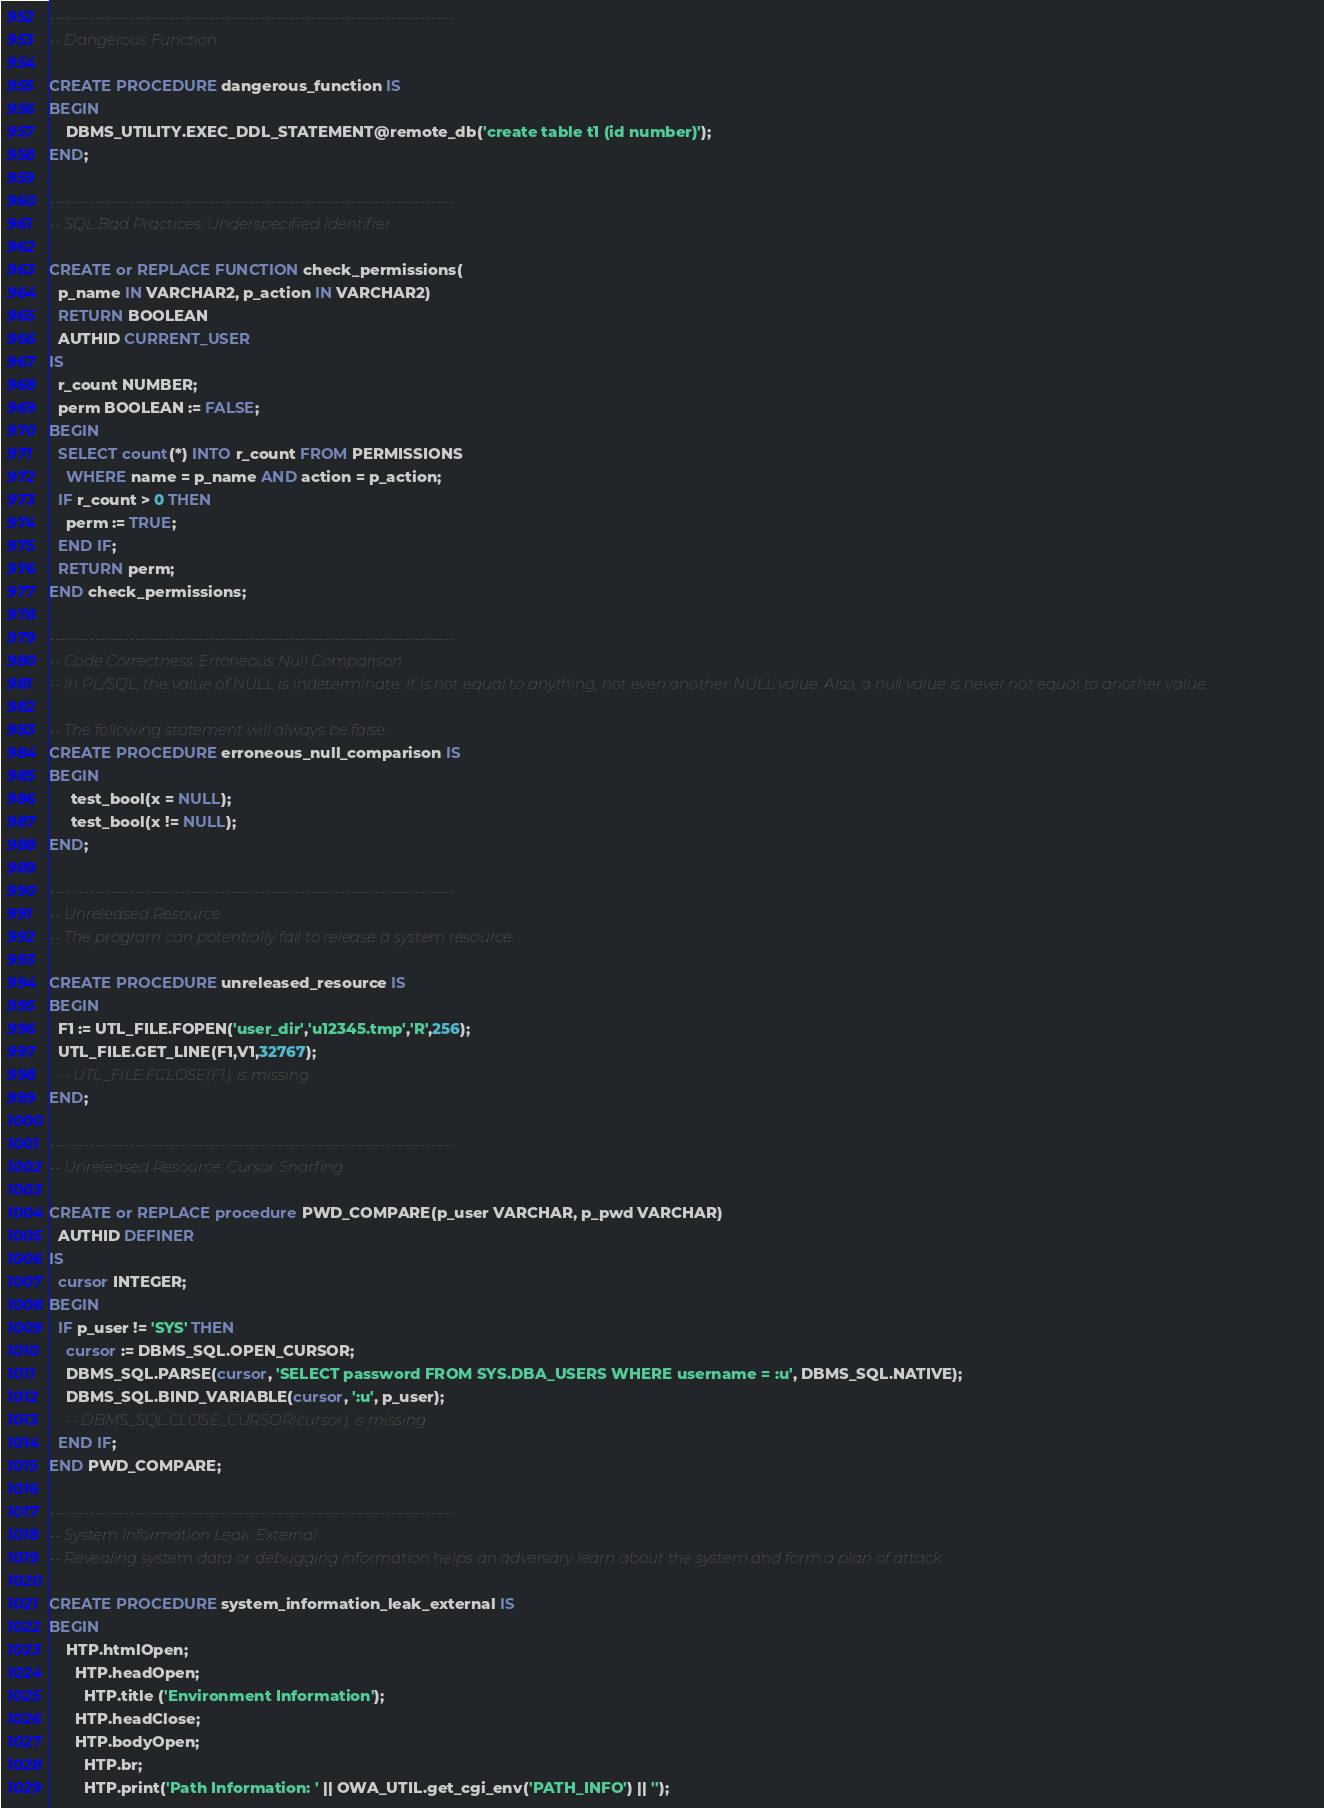<code> <loc_0><loc_0><loc_500><loc_500><_SQL_>-----------------------------------------------------------------------
-- Dangerous Function

CREATE PROCEDURE dangerous_function IS
BEGIN
    DBMS_UTILITY.EXEC_DDL_STATEMENT@remote_db('create table t1 (id number)');
END;

-----------------------------------------------------------------------
-- SQL Bad Practices: Underspecified Identifier

CREATE or REPLACE FUNCTION check_permissions(
  p_name IN VARCHAR2, p_action IN VARCHAR2)
  RETURN BOOLEAN
  AUTHID CURRENT_USER
IS
  r_count NUMBER;
  perm BOOLEAN := FALSE;
BEGIN
  SELECT count(*) INTO r_count FROM PERMISSIONS
    WHERE name = p_name AND action = p_action;
  IF r_count > 0 THEN
    perm := TRUE;
  END IF;
  RETURN perm;
END check_permissions;

-----------------------------------------------------------------------
-- Code Correctness: Erroneous Null Comparison
-- In PL/SQL, the value of NULL is indeterminate. It is not equal to anything, not even another NULL value. Also, a null value is never not equal to another value.

-- The following statement will always be false.
CREATE PROCEDURE erroneous_null_comparison IS
BEGIN
     test_bool(x = NULL);
     test_bool(x != NULL);
END;

-----------------------------------------------------------------------
-- Unreleased Resource
-- The program can potentially fail to release a system resource.

CREATE PROCEDURE unreleased_resource IS
BEGIN
  F1 := UTL_FILE.FOPEN('user_dir','u12345.tmp','R',256);
  UTL_FILE.GET_LINE(F1,V1,32767);
  -- UTL_FILE.FCLOSE(F1); is missing
END;

-----------------------------------------------------------------------
-- Unreleased Resource: Cursor Snarfing

CREATE or REPLACE procedure PWD_COMPARE(p_user VARCHAR, p_pwd VARCHAR)
  AUTHID DEFINER
IS
  cursor INTEGER;
BEGIN
  IF p_user != 'SYS' THEN
    cursor := DBMS_SQL.OPEN_CURSOR;
    DBMS_SQL.PARSE(cursor, 'SELECT password FROM SYS.DBA_USERS WHERE username = :u', DBMS_SQL.NATIVE);
    DBMS_SQL.BIND_VARIABLE(cursor, ':u', p_user);
    -- DBMS_SQL.CLOSE_CURSOR(cursor); is missing
  END IF;
END PWD_COMPARE;

-----------------------------------------------------------------------
-- System Information Leak: External
-- Revealing system data or debugging information helps an adversary learn about the system and form a plan of attack.

CREATE PROCEDURE system_information_leak_external IS
BEGIN
    HTP.htmlOpen;
      HTP.headOpen;
        HTP.title ('Environment Information');
      HTP.headClose;
      HTP.bodyOpen;
        HTP.br;
        HTP.print('Path Information: ' || OWA_UTIL.get_cgi_env('PATH_INFO') || '');</code> 